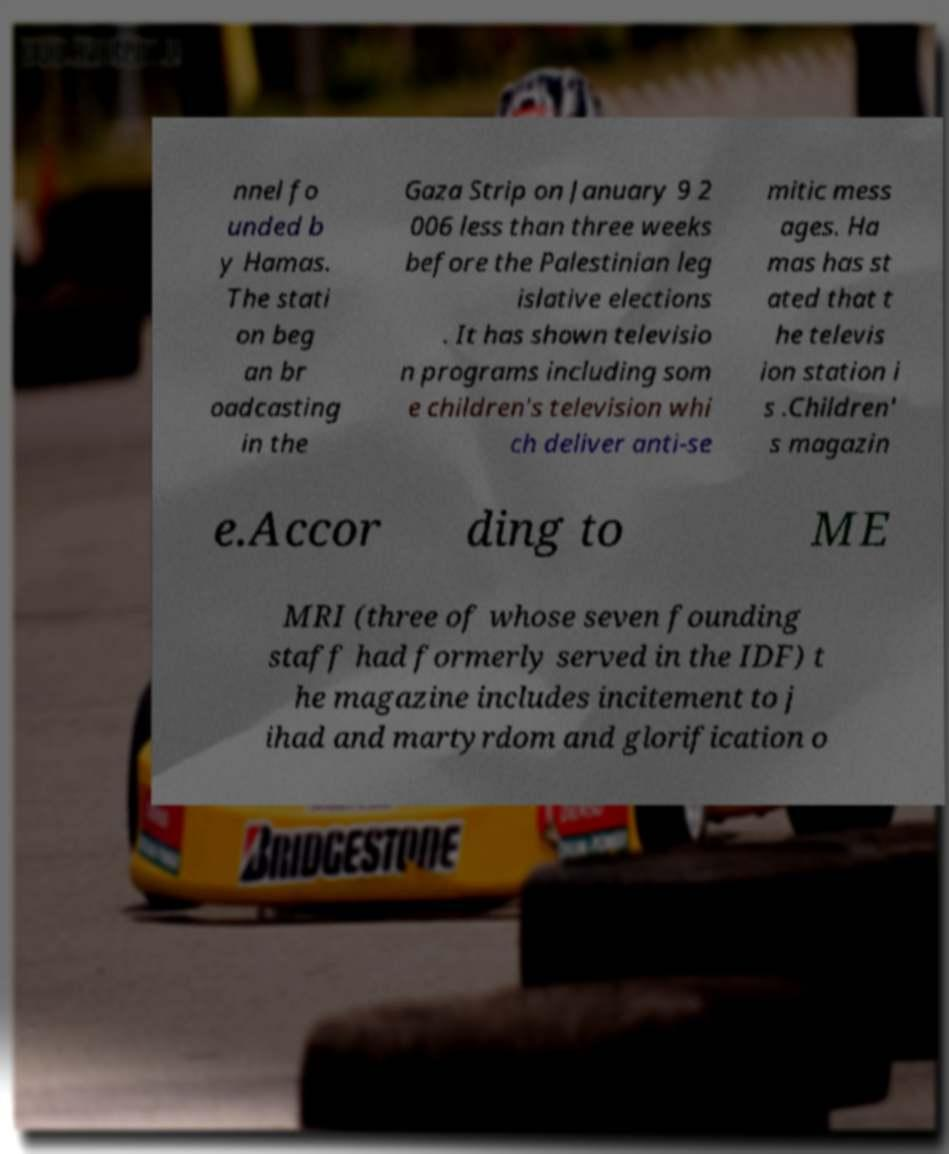There's text embedded in this image that I need extracted. Can you transcribe it verbatim? nnel fo unded b y Hamas. The stati on beg an br oadcasting in the Gaza Strip on January 9 2 006 less than three weeks before the Palestinian leg islative elections . It has shown televisio n programs including som e children's television whi ch deliver anti-se mitic mess ages. Ha mas has st ated that t he televis ion station i s .Children' s magazin e.Accor ding to ME MRI (three of whose seven founding staff had formerly served in the IDF) t he magazine includes incitement to j ihad and martyrdom and glorification o 